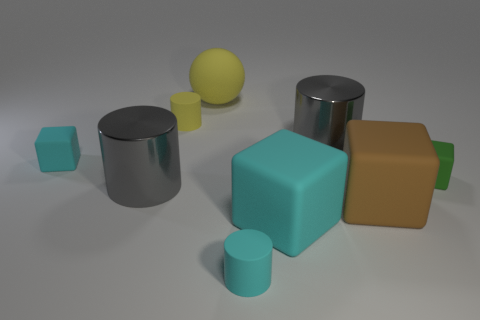The big rubber block to the left of the big brown matte thing is what color?
Offer a very short reply. Cyan. What number of big cylinders have the same color as the large rubber ball?
Keep it short and to the point. 0. Is the number of big brown things to the left of the small cyan cylinder less than the number of balls that are in front of the big brown thing?
Your response must be concise. No. There is a tiny green rubber thing; what number of brown rubber objects are to the right of it?
Offer a very short reply. 0. Is there a brown object that has the same material as the tiny yellow cylinder?
Ensure brevity in your answer.  Yes. Are there more large rubber objects in front of the green thing than tiny green blocks that are on the left side of the small cyan block?
Ensure brevity in your answer.  Yes. What size is the green matte block?
Ensure brevity in your answer.  Small. What is the shape of the big metal object to the left of the cyan rubber cylinder?
Your answer should be compact. Cylinder. Is the tiny green object the same shape as the big yellow matte object?
Your answer should be compact. No. Are there the same number of large things behind the sphere and small brown metallic balls?
Your answer should be very brief. Yes. 